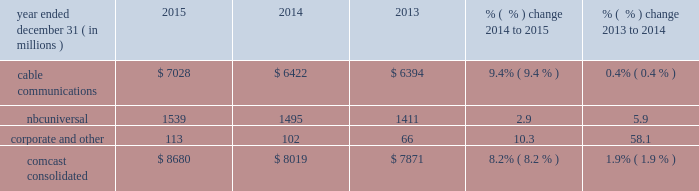Consolidated costs and expenses the following graph illustrates the contributions to the increases in consolidated operating costs and expenses by our cable communications and nbcuniversal segments , as well as our corporate and other activities .
$ 43000 $ 44000 $ 45000 $ 46000 $ 47000 $ 48000 $ 50000 $ 49000 2013 2015cable communications segment nbcuniversal segments corporate and other 2014 cable communications segment nbcuniversal segments corporate and other $ 43223 $ 1397 $ 41 $ 49832 $ 310 $ 45852 $ 1731 $ 2208 our consolidated operating costs and expenses in 2015 included expenses associated with our broadcast of the 2015 super bowl and our larger film slate , both of which are included in our nbcuniversal segments .
Our consolidated operating costs and expenses in 2014 included expenses associated with our broadcast of the 2014 sochi olympics , which is reported in our nbcuniversal segments .
Our consolidated operating costs and expenses also included transaction-related costs associated with the time warner cable merger and the related divestiture transactions of $ 178 million and $ 237 million in 2015 and 2014 , respectively , which is included in corporate and other .
On april 24 , 2015 , we and time warner cable inc .
Terminated our planned merger and we terminated our related agreement with charter communications , inc .
To spin off , exchange and sell certain cable systems .
Operating costs and expenses for our segments is discussed separately below under the heading 201csegment operating results . 201d operating costs and expenses for our other businesses is discussed separately below under the heading 201ccorporate and other results of operations . 201d consolidated depreciation and amortization year ended december 31 ( in millions ) 2015 2014 2013 % (  % ) change 2014 to 2015 % (  % ) change 2013 to 2014 .
Consolidated depreciation and amortization expenses increased in 2015 primarily due to increases in capital expenditures , as well as expenditures for software , in our cable communications segment in recent years .
We continue to invest in customer premise equipment , primarily for our x1 platform , wireless gateways and cloud dvr technology , and in equipment to increase our network capacity .
In addition , because these assets generally have shorter estimated useful lives , our depreciation expenses have increased , which we expect will 47 comcast 2015 annual report on form 10-k .
What was the ratio of the operating costs and expenses for cable communications compared to nbcuniversal in 2015? 
Computations: (7028 / 1539)
Answer: 4.5666. 